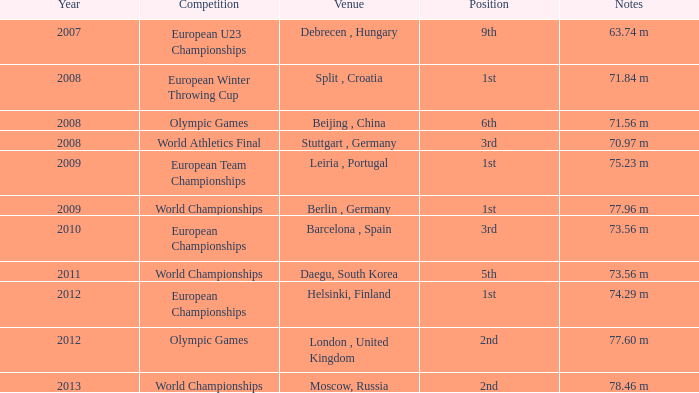What was the venue after 2012? Moscow, Russia. 